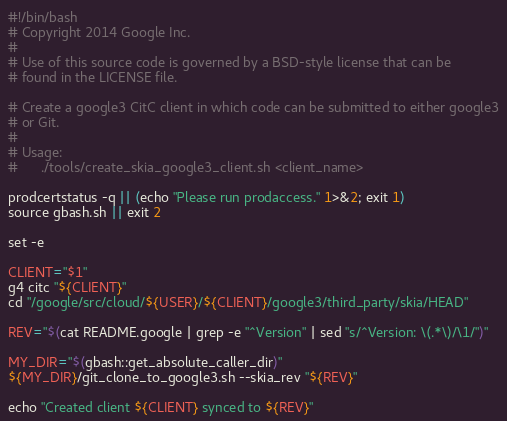Convert code to text. <code><loc_0><loc_0><loc_500><loc_500><_Bash_>#!/bin/bash
# Copyright 2014 Google Inc.
#
# Use of this source code is governed by a BSD-style license that can be
# found in the LICENSE file.

# Create a google3 CitC client in which code can be submitted to either google3
# or Git.
#
# Usage:
#      ./tools/create_skia_google3_client.sh <client_name>

prodcertstatus -q || (echo "Please run prodaccess." 1>&2; exit 1)
source gbash.sh || exit 2

set -e

CLIENT="$1"
g4 citc "${CLIENT}"
cd "/google/src/cloud/${USER}/${CLIENT}/google3/third_party/skia/HEAD"

REV="$(cat README.google | grep -e "^Version" | sed "s/^Version: \(.*\)/\1/")"

MY_DIR="$(gbash::get_absolute_caller_dir)"
${MY_DIR}/git_clone_to_google3.sh --skia_rev "${REV}"

echo "Created client ${CLIENT} synced to ${REV}"
</code> 